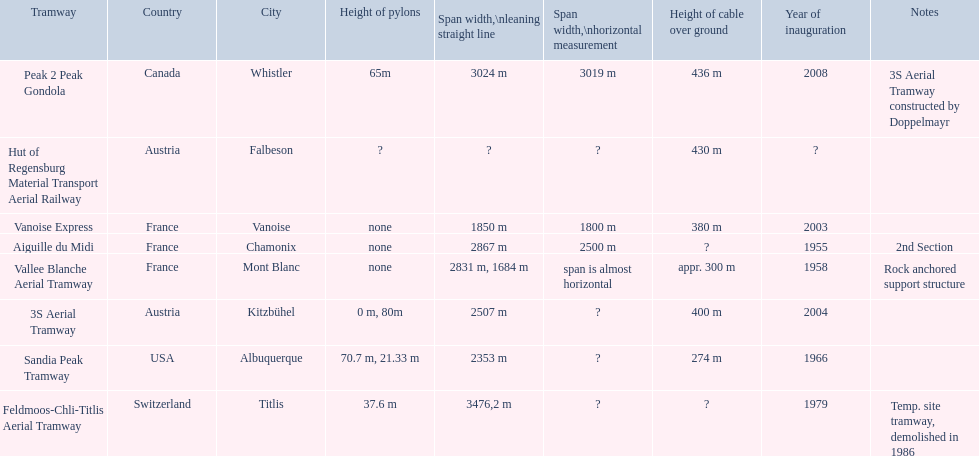Was the sandia peak tramway inaugurated before or after the 3s aerial tramway? Before. 